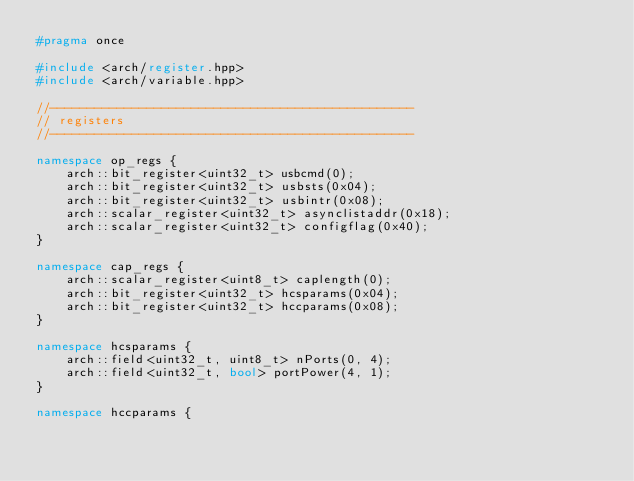Convert code to text. <code><loc_0><loc_0><loc_500><loc_500><_C++_>#pragma once

#include <arch/register.hpp>
#include <arch/variable.hpp>

//-------------------------------------------------
// registers
//-------------------------------------------------

namespace op_regs {
	arch::bit_register<uint32_t> usbcmd(0);
	arch::bit_register<uint32_t> usbsts(0x04);
	arch::bit_register<uint32_t> usbintr(0x08);
	arch::scalar_register<uint32_t> asynclistaddr(0x18);
	arch::scalar_register<uint32_t> configflag(0x40);
}

namespace cap_regs {
	arch::scalar_register<uint8_t> caplength(0);
	arch::bit_register<uint32_t> hcsparams(0x04);
	arch::bit_register<uint32_t> hccparams(0x08);
}

namespace hcsparams {
	arch::field<uint32_t, uint8_t> nPorts(0, 4);
	arch::field<uint32_t, bool> portPower(4, 1);
}

namespace hccparams {</code> 